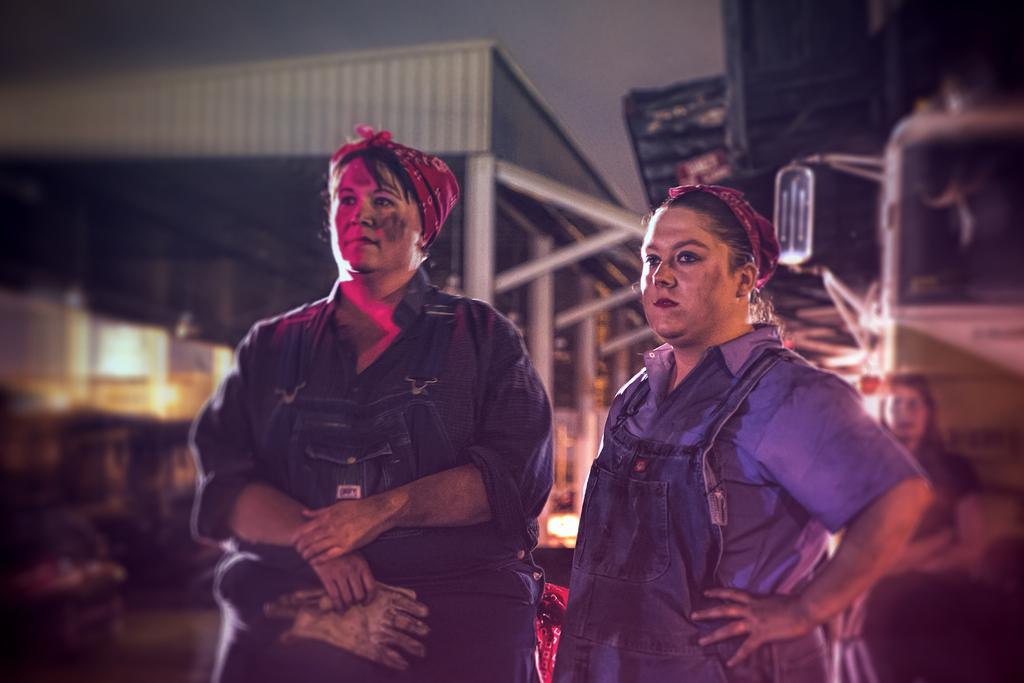How many people are present in the image? There are two people standing in the image. What is the man holding in the image? The man is holding a glove. What can be seen in the background of the image? There is a shed, rods, a vehicle, lights, and the sky visible in the background of the image. What type of chicken is sitting on the loaf in the image? There is no chicken or loaf present in the image. Where is the faucet located in the image? There is no faucet present in the image. 